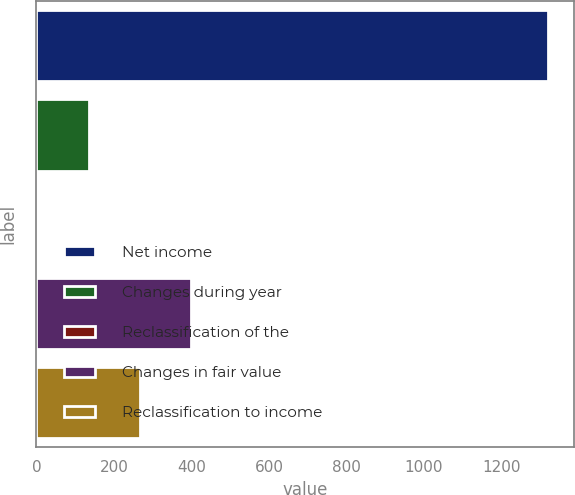Convert chart. <chart><loc_0><loc_0><loc_500><loc_500><bar_chart><fcel>Net income<fcel>Changes during year<fcel>Reclassification of the<fcel>Changes in fair value<fcel>Reclassification to income<nl><fcel>1321<fcel>134.8<fcel>3<fcel>398.4<fcel>266.6<nl></chart> 